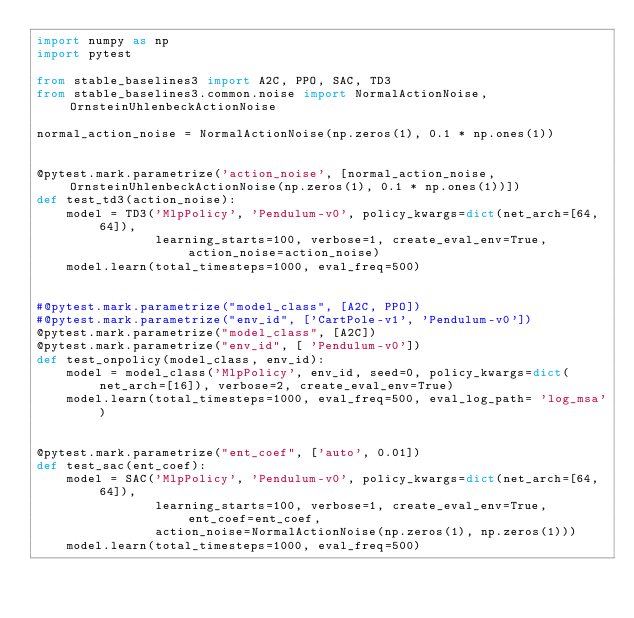<code> <loc_0><loc_0><loc_500><loc_500><_Python_>import numpy as np
import pytest

from stable_baselines3 import A2C, PPO, SAC, TD3
from stable_baselines3.common.noise import NormalActionNoise, OrnsteinUhlenbeckActionNoise

normal_action_noise = NormalActionNoise(np.zeros(1), 0.1 * np.ones(1))


@pytest.mark.parametrize('action_noise', [normal_action_noise, OrnsteinUhlenbeckActionNoise(np.zeros(1), 0.1 * np.ones(1))])
def test_td3(action_noise):
    model = TD3('MlpPolicy', 'Pendulum-v0', policy_kwargs=dict(net_arch=[64, 64]),
                learning_starts=100, verbose=1, create_eval_env=True, action_noise=action_noise)
    model.learn(total_timesteps=1000, eval_freq=500)


#@pytest.mark.parametrize("model_class", [A2C, PPO])
#@pytest.mark.parametrize("env_id", ['CartPole-v1', 'Pendulum-v0'])
@pytest.mark.parametrize("model_class", [A2C])
@pytest.mark.parametrize("env_id", [ 'Pendulum-v0'])
def test_onpolicy(model_class, env_id):
    model = model_class('MlpPolicy', env_id, seed=0, policy_kwargs=dict(net_arch=[16]), verbose=2, create_eval_env=True)
    model.learn(total_timesteps=1000, eval_freq=500, eval_log_path= 'log_msa')


@pytest.mark.parametrize("ent_coef", ['auto', 0.01])
def test_sac(ent_coef):
    model = SAC('MlpPolicy', 'Pendulum-v0', policy_kwargs=dict(net_arch=[64, 64]),
                learning_starts=100, verbose=1, create_eval_env=True, ent_coef=ent_coef,
                action_noise=NormalActionNoise(np.zeros(1), np.zeros(1)))
    model.learn(total_timesteps=1000, eval_freq=500)
</code> 